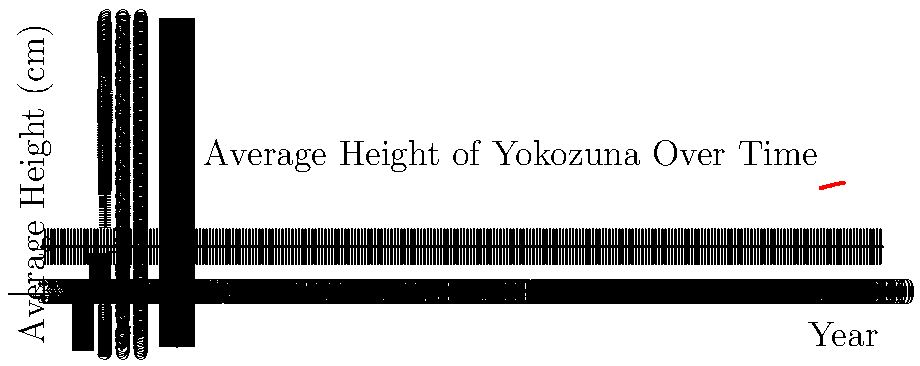Based on the line graph showing the average height of Yokozuna from 1950 to 2020, what was the approximate increase in average height between 1970 and 2000? To find the increase in average height between 1970 and 2000:

1. Locate the height value for 1970 on the graph: approximately 183 cm
2. Locate the height value for 2000 on the graph: approximately 190 cm
3. Calculate the difference: 190 cm - 183 cm = 7 cm

The line graph shows a steady increase in the average height of Yokozuna over time. The change between 1970 and 2000 represents a significant portion of this overall trend, reflecting the evolution of the sport during your career and the changing physical attributes of top-level sumo wrestlers.
Answer: 7 cm 